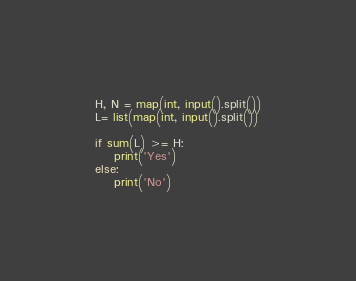Convert code to text. <code><loc_0><loc_0><loc_500><loc_500><_Python_>H, N = map(int, input().split())
L= list(map(int, input().split())

if sum(L) >= H:
	print('Yes')
else:
	print('No')</code> 